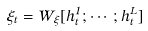Convert formula to latex. <formula><loc_0><loc_0><loc_500><loc_500>\xi _ { t } = W _ { \xi } [ h _ { t } ^ { 1 } ; \cdots ; h _ { t } ^ { L } ]</formula> 